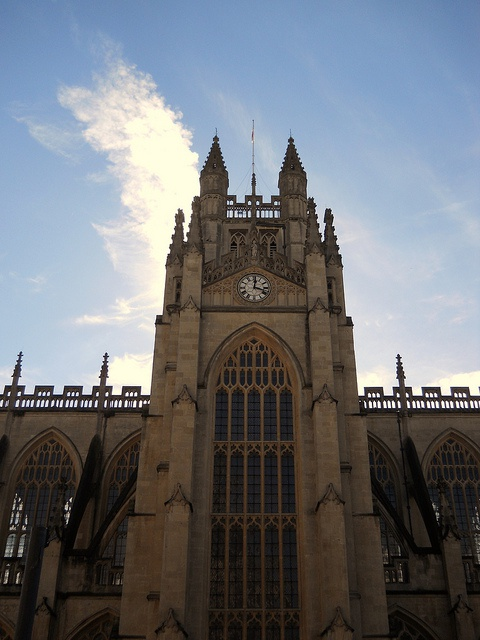Describe the objects in this image and their specific colors. I can see a clock in gray and black tones in this image. 